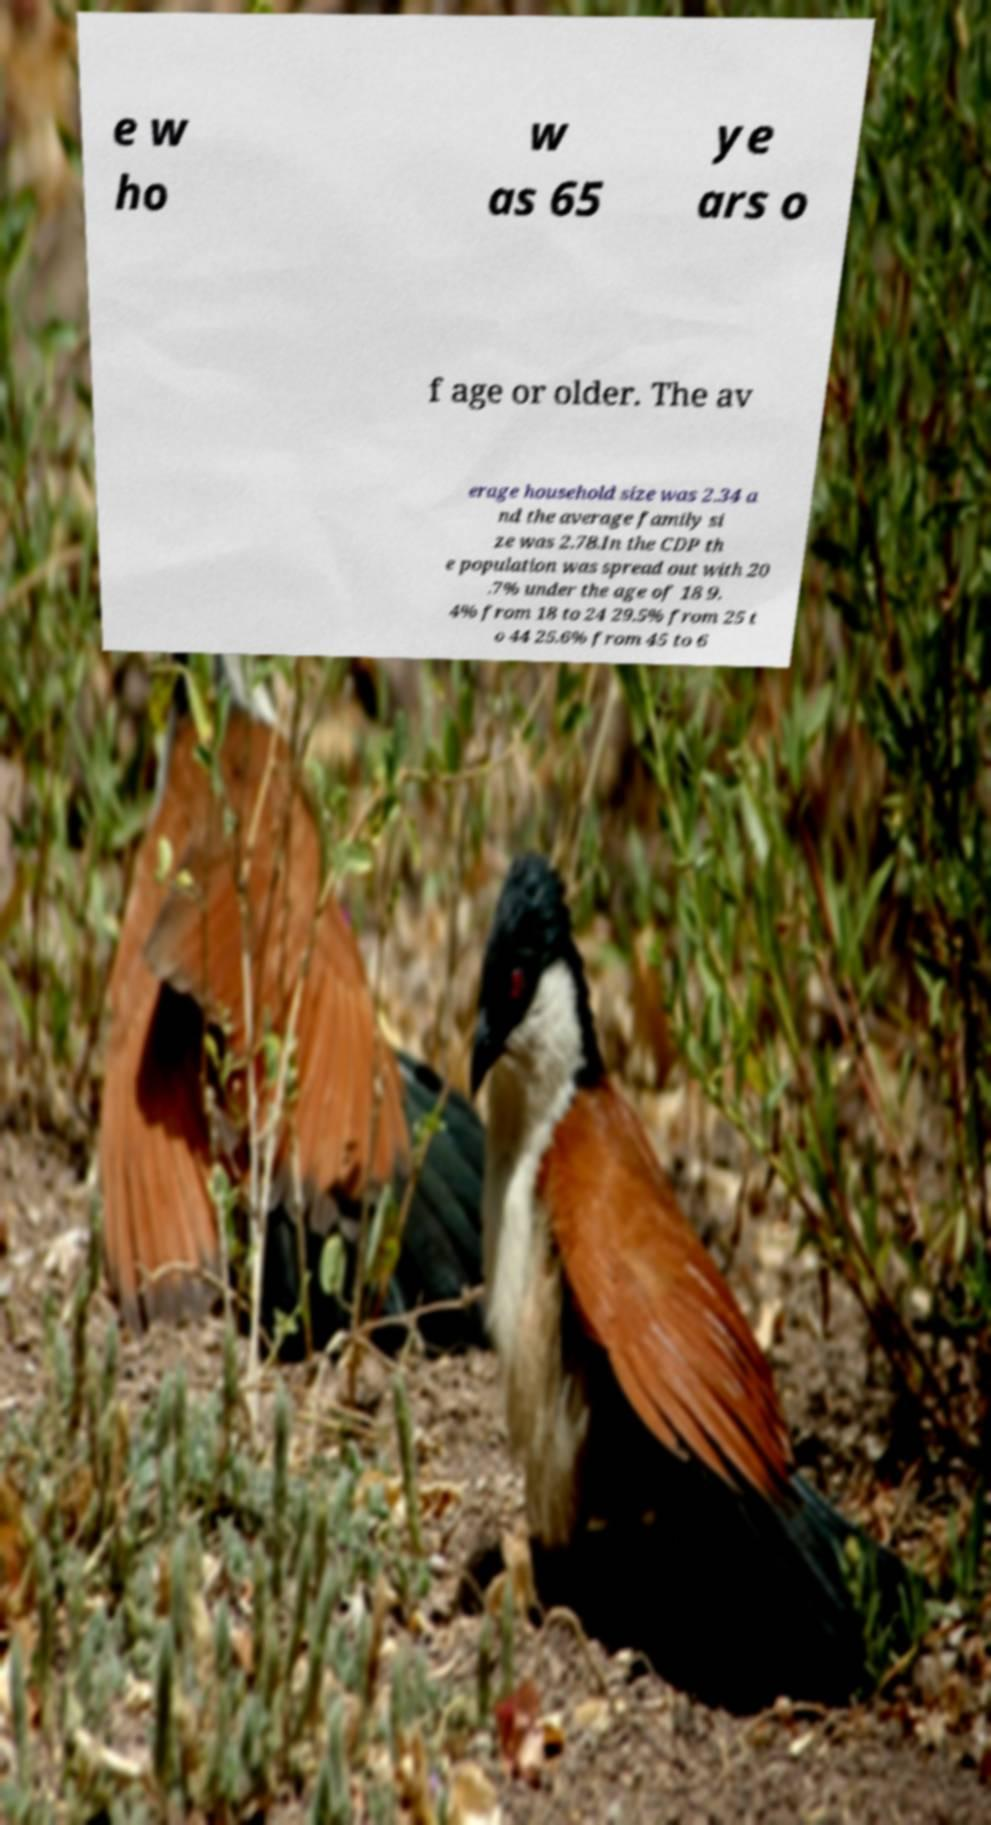Could you extract and type out the text from this image? e w ho w as 65 ye ars o f age or older. The av erage household size was 2.34 a nd the average family si ze was 2.78.In the CDP th e population was spread out with 20 .7% under the age of 18 9. 4% from 18 to 24 29.5% from 25 t o 44 25.6% from 45 to 6 